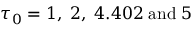Convert formula to latex. <formula><loc_0><loc_0><loc_500><loc_500>\tau _ { 0 } = 1 , \, 2 , \, 4 . 4 0 2 \, a n d \, 5</formula> 